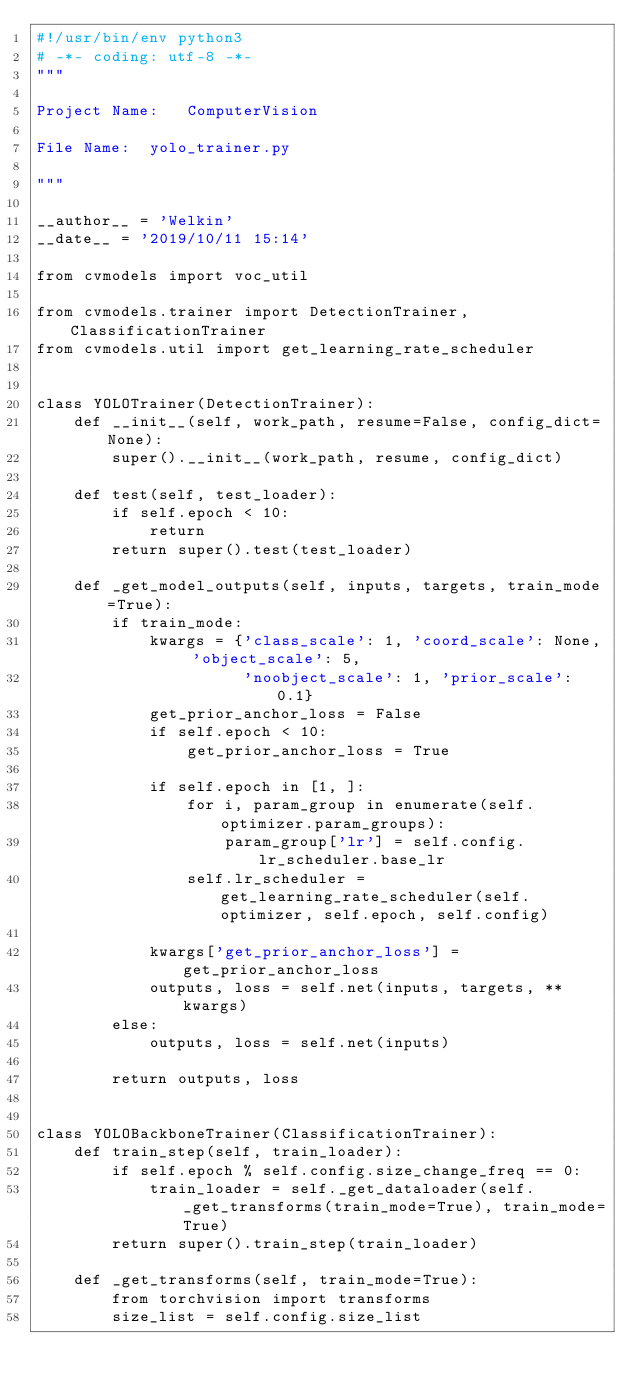Convert code to text. <code><loc_0><loc_0><loc_500><loc_500><_Python_>#!/usr/bin/env python3
# -*- coding: utf-8 -*-
"""

Project Name:   ComputerVision

File Name:  yolo_trainer.py

"""

__author__ = 'Welkin'
__date__ = '2019/10/11 15:14'

from cvmodels import voc_util

from cvmodels.trainer import DetectionTrainer, ClassificationTrainer
from cvmodels.util import get_learning_rate_scheduler


class YOLOTrainer(DetectionTrainer):
    def __init__(self, work_path, resume=False, config_dict=None):
        super().__init__(work_path, resume, config_dict)

    def test(self, test_loader):
        if self.epoch < 10:
            return
        return super().test(test_loader)

    def _get_model_outputs(self, inputs, targets, train_mode=True):
        if train_mode:
            kwargs = {'class_scale': 1, 'coord_scale': None, 'object_scale': 5,
                      'noobject_scale': 1, 'prior_scale': 0.1}
            get_prior_anchor_loss = False
            if self.epoch < 10:
                get_prior_anchor_loss = True

            if self.epoch in [1, ]:
                for i, param_group in enumerate(self.optimizer.param_groups):
                    param_group['lr'] = self.config.lr_scheduler.base_lr
                self.lr_scheduler = get_learning_rate_scheduler(self.optimizer, self.epoch, self.config)

            kwargs['get_prior_anchor_loss'] = get_prior_anchor_loss
            outputs, loss = self.net(inputs, targets, **kwargs)
        else:
            outputs, loss = self.net(inputs)

        return outputs, loss


class YOLOBackboneTrainer(ClassificationTrainer):
    def train_step(self, train_loader):
        if self.epoch % self.config.size_change_freq == 0:
            train_loader = self._get_dataloader(self._get_transforms(train_mode=True), train_mode=True)
        return super().train_step(train_loader)

    def _get_transforms(self, train_mode=True):
        from torchvision import transforms
        size_list = self.config.size_list</code> 